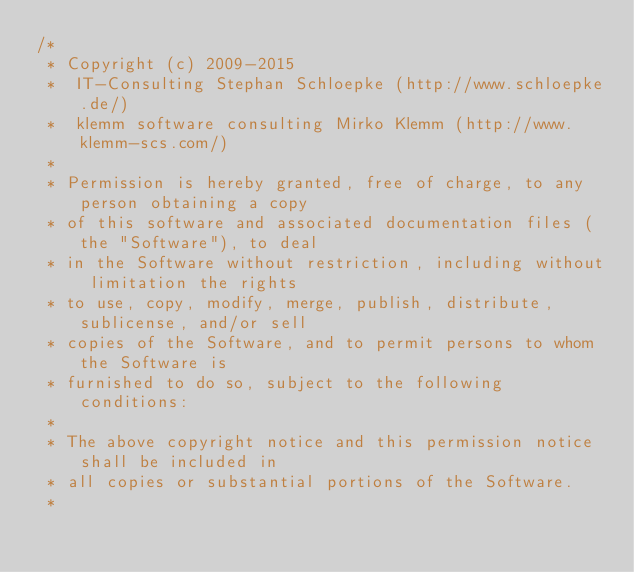Convert code to text. <code><loc_0><loc_0><loc_500><loc_500><_Java_>/*
 * Copyright (c) 2009-2015
 * 	IT-Consulting Stephan Schloepke (http://www.schloepke.de/)
 * 	klemm software consulting Mirko Klemm (http://www.klemm-scs.com/)
 *
 * Permission is hereby granted, free of charge, to any person obtaining a copy
 * of this software and associated documentation files (the "Software"), to deal
 * in the Software without restriction, including without limitation the rights
 * to use, copy, modify, merge, publish, distribute, sublicense, and/or sell
 * copies of the Software, and to permit persons to whom the Software is
 * furnished to do so, subject to the following conditions:
 *
 * The above copyright notice and this permission notice shall be included in
 * all copies or substantial portions of the Software.
 *</code> 